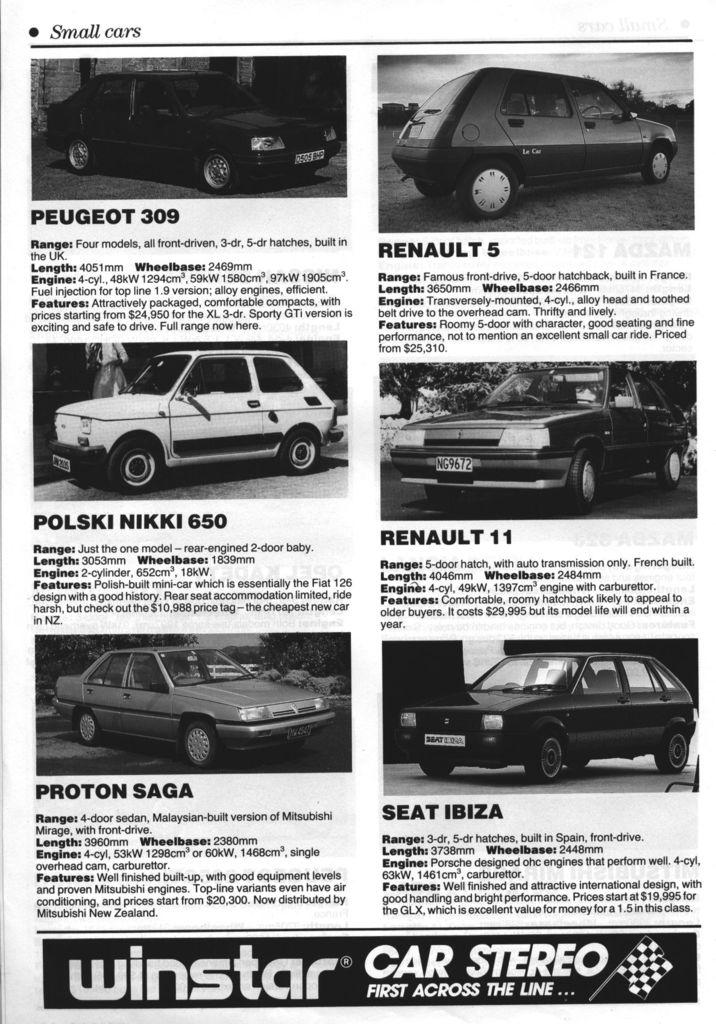What types of vehicles are present in the image? There are cars of different companies in the image. Can you describe the variety of cars in the image? The image shows cars from different companies, but specific details about the models or brands cannot be determined from the provided facts. What type of loaf is being used to make observations about the cars in the image? There is no loaf present in the image, and observations about the cars are not being made using any loaf. 